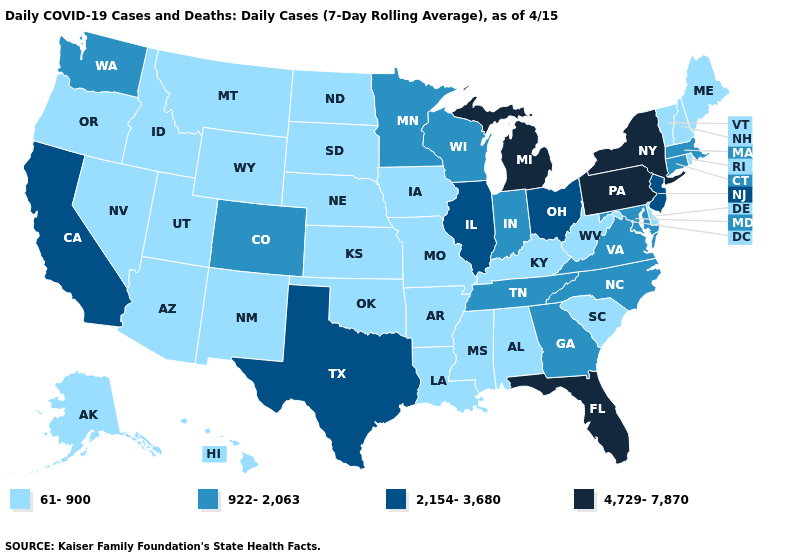Name the states that have a value in the range 61-900?
Keep it brief. Alabama, Alaska, Arizona, Arkansas, Delaware, Hawaii, Idaho, Iowa, Kansas, Kentucky, Louisiana, Maine, Mississippi, Missouri, Montana, Nebraska, Nevada, New Hampshire, New Mexico, North Dakota, Oklahoma, Oregon, Rhode Island, South Carolina, South Dakota, Utah, Vermont, West Virginia, Wyoming. Name the states that have a value in the range 2,154-3,680?
Give a very brief answer. California, Illinois, New Jersey, Ohio, Texas. Name the states that have a value in the range 4,729-7,870?
Short answer required. Florida, Michigan, New York, Pennsylvania. Does the map have missing data?
Short answer required. No. How many symbols are there in the legend?
Quick response, please. 4. How many symbols are there in the legend?
Be succinct. 4. Does Minnesota have the lowest value in the MidWest?
Keep it brief. No. What is the highest value in states that border Florida?
Keep it brief. 922-2,063. Does Kansas have the same value as Utah?
Be succinct. Yes. Is the legend a continuous bar?
Keep it brief. No. Name the states that have a value in the range 2,154-3,680?
Write a very short answer. California, Illinois, New Jersey, Ohio, Texas. Name the states that have a value in the range 2,154-3,680?
Answer briefly. California, Illinois, New Jersey, Ohio, Texas. Name the states that have a value in the range 4,729-7,870?
Quick response, please. Florida, Michigan, New York, Pennsylvania. What is the lowest value in the MidWest?
Quick response, please. 61-900. Which states hav the highest value in the West?
Write a very short answer. California. 